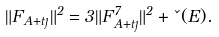Convert formula to latex. <formula><loc_0><loc_0><loc_500><loc_500>\| F _ { A + t \eta } \| ^ { 2 } = 3 \| F ^ { 7 } _ { A + t \eta } \| ^ { 2 } + \kappa ( E ) .</formula> 